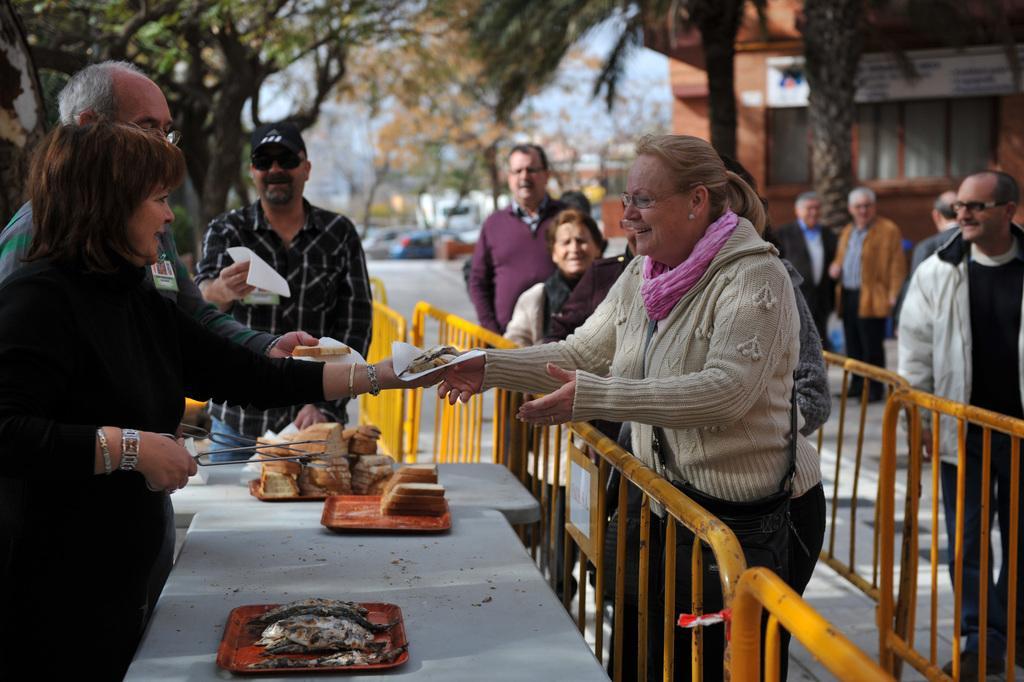How would you summarize this image in a sentence or two? People are standing, on the table we have food,tray and in the back there are trees and building. 